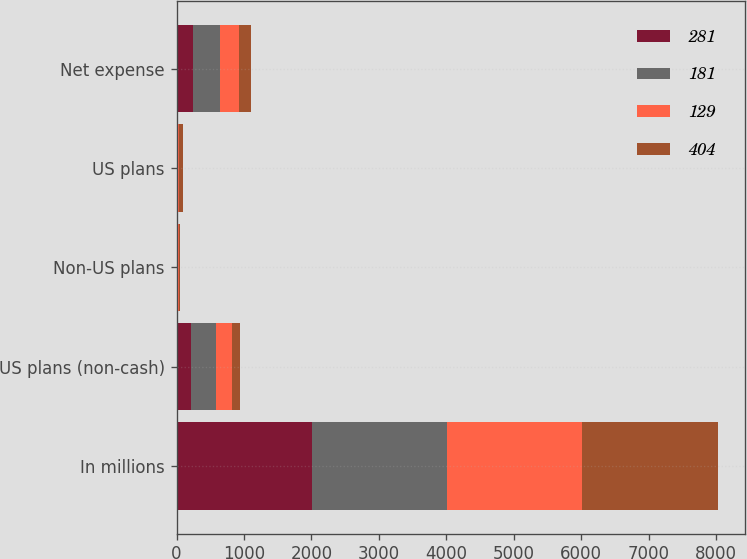Convert chart. <chart><loc_0><loc_0><loc_500><loc_500><stacked_bar_chart><ecel><fcel>In millions<fcel>US plans (non-cash)<fcel>Non-US plans<fcel>US plans<fcel>Net expense<nl><fcel>281<fcel>2007<fcel>210<fcel>5<fcel>15<fcel>238<nl><fcel>181<fcel>2006<fcel>377<fcel>17<fcel>7<fcel>404<nl><fcel>129<fcel>2005<fcel>243<fcel>15<fcel>20<fcel>281<nl><fcel>404<fcel>2004<fcel>111<fcel>15<fcel>53<fcel>181<nl></chart> 